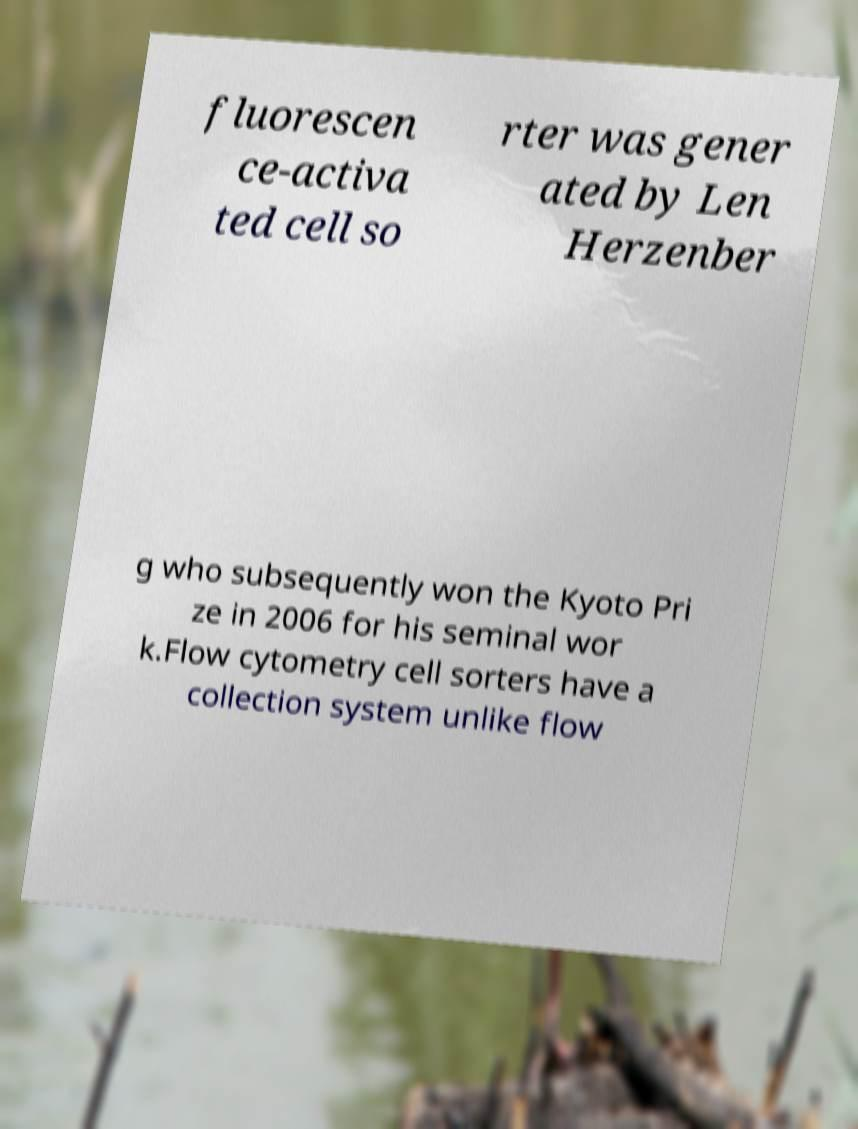Could you extract and type out the text from this image? fluorescen ce-activa ted cell so rter was gener ated by Len Herzenber g who subsequently won the Kyoto Pri ze in 2006 for his seminal wor k.Flow cytometry cell sorters have a collection system unlike flow 